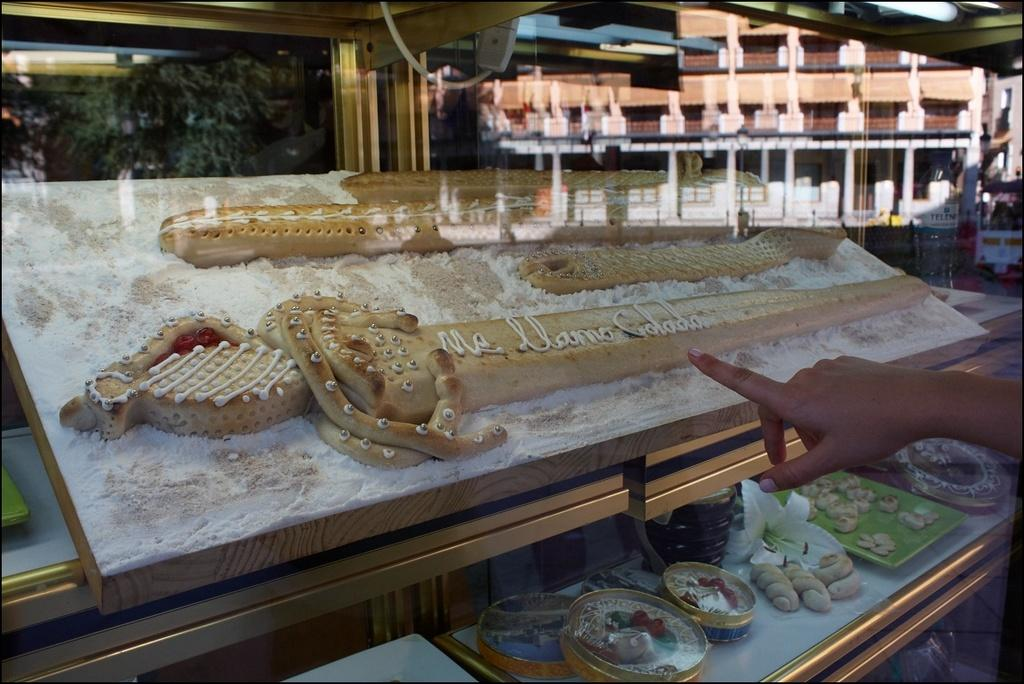What is the main subject in the foreground of the image? There is a bread sword in the foreground of the image. Are there any other bread objects visible in the foreground? Yes, there are other bread objects in the foreground. How many boxes can be seen in the image? There are three boxes in the image. What type of plant is present in the image? There is a flower in the image. What type of food is present in the image? There is bread and food in a platter inside a glass in the image. How many women are present in the image? There is no mention of women in the image, so it cannot be determined how many are present. 